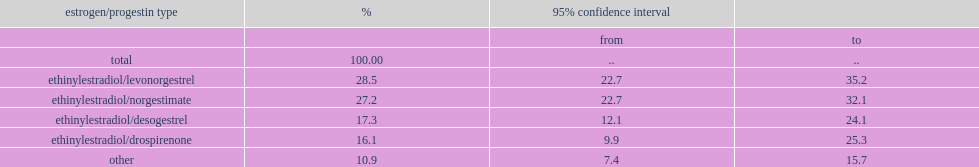What was the proportion of participants that took ocs containing ee in combination with levonorgestrel or norgestimate? 55.7. What was the proportion of oc users that took desogestrel-containing formulations? 17.3. What was the proportion of oc users that took drospirenone-containing formulations? 16.1. 